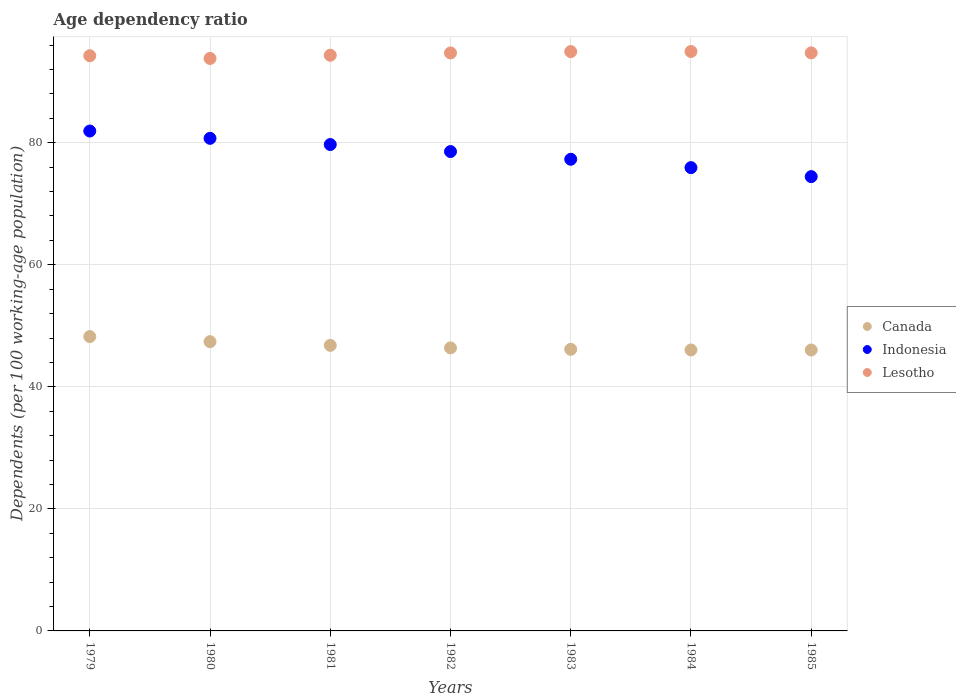What is the age dependency ratio in in Lesotho in 1982?
Provide a short and direct response. 94.71. Across all years, what is the maximum age dependency ratio in in Indonesia?
Keep it short and to the point. 81.92. Across all years, what is the minimum age dependency ratio in in Indonesia?
Make the answer very short. 74.45. In which year was the age dependency ratio in in Indonesia maximum?
Your answer should be compact. 1979. What is the total age dependency ratio in in Canada in the graph?
Your response must be concise. 327.02. What is the difference between the age dependency ratio in in Canada in 1981 and that in 1984?
Ensure brevity in your answer.  0.75. What is the difference between the age dependency ratio in in Indonesia in 1983 and the age dependency ratio in in Lesotho in 1981?
Make the answer very short. -17.04. What is the average age dependency ratio in in Canada per year?
Your answer should be compact. 46.72. In the year 1985, what is the difference between the age dependency ratio in in Lesotho and age dependency ratio in in Canada?
Provide a succinct answer. 48.69. What is the ratio of the age dependency ratio in in Canada in 1980 to that in 1981?
Provide a short and direct response. 1.01. Is the age dependency ratio in in Indonesia in 1984 less than that in 1985?
Make the answer very short. No. What is the difference between the highest and the second highest age dependency ratio in in Canada?
Your answer should be compact. 0.84. What is the difference between the highest and the lowest age dependency ratio in in Canada?
Offer a terse response. 2.2. In how many years, is the age dependency ratio in in Canada greater than the average age dependency ratio in in Canada taken over all years?
Your answer should be very brief. 3. Is the age dependency ratio in in Indonesia strictly greater than the age dependency ratio in in Lesotho over the years?
Give a very brief answer. No. How many dotlines are there?
Give a very brief answer. 3. How many years are there in the graph?
Give a very brief answer. 7. Are the values on the major ticks of Y-axis written in scientific E-notation?
Provide a succinct answer. No. Does the graph contain any zero values?
Offer a very short reply. No. How are the legend labels stacked?
Give a very brief answer. Vertical. What is the title of the graph?
Your answer should be compact. Age dependency ratio. What is the label or title of the X-axis?
Your response must be concise. Years. What is the label or title of the Y-axis?
Ensure brevity in your answer.  Dependents (per 100 working-age population). What is the Dependents (per 100 working-age population) of Canada in 1979?
Offer a very short reply. 48.24. What is the Dependents (per 100 working-age population) in Indonesia in 1979?
Your response must be concise. 81.92. What is the Dependents (per 100 working-age population) in Lesotho in 1979?
Offer a terse response. 94.26. What is the Dependents (per 100 working-age population) in Canada in 1980?
Offer a terse response. 47.4. What is the Dependents (per 100 working-age population) in Indonesia in 1980?
Make the answer very short. 80.72. What is the Dependents (per 100 working-age population) in Lesotho in 1980?
Offer a terse response. 93.81. What is the Dependents (per 100 working-age population) of Canada in 1981?
Your response must be concise. 46.79. What is the Dependents (per 100 working-age population) in Indonesia in 1981?
Provide a short and direct response. 79.7. What is the Dependents (per 100 working-age population) in Lesotho in 1981?
Provide a short and direct response. 94.34. What is the Dependents (per 100 working-age population) of Canada in 1982?
Make the answer very short. 46.38. What is the Dependents (per 100 working-age population) in Indonesia in 1982?
Offer a terse response. 78.55. What is the Dependents (per 100 working-age population) of Lesotho in 1982?
Your response must be concise. 94.71. What is the Dependents (per 100 working-age population) of Canada in 1983?
Your answer should be compact. 46.14. What is the Dependents (per 100 working-age population) of Indonesia in 1983?
Make the answer very short. 77.29. What is the Dependents (per 100 working-age population) in Lesotho in 1983?
Give a very brief answer. 94.93. What is the Dependents (per 100 working-age population) of Canada in 1984?
Your response must be concise. 46.04. What is the Dependents (per 100 working-age population) of Indonesia in 1984?
Your response must be concise. 75.92. What is the Dependents (per 100 working-age population) in Lesotho in 1984?
Offer a terse response. 94.95. What is the Dependents (per 100 working-age population) in Canada in 1985?
Your answer should be compact. 46.03. What is the Dependents (per 100 working-age population) in Indonesia in 1985?
Make the answer very short. 74.45. What is the Dependents (per 100 working-age population) of Lesotho in 1985?
Your answer should be very brief. 94.73. Across all years, what is the maximum Dependents (per 100 working-age population) of Canada?
Your answer should be compact. 48.24. Across all years, what is the maximum Dependents (per 100 working-age population) in Indonesia?
Offer a very short reply. 81.92. Across all years, what is the maximum Dependents (per 100 working-age population) of Lesotho?
Make the answer very short. 94.95. Across all years, what is the minimum Dependents (per 100 working-age population) in Canada?
Offer a terse response. 46.03. Across all years, what is the minimum Dependents (per 100 working-age population) of Indonesia?
Your answer should be very brief. 74.45. Across all years, what is the minimum Dependents (per 100 working-age population) in Lesotho?
Ensure brevity in your answer.  93.81. What is the total Dependents (per 100 working-age population) of Canada in the graph?
Ensure brevity in your answer.  327.02. What is the total Dependents (per 100 working-age population) of Indonesia in the graph?
Provide a succinct answer. 548.55. What is the total Dependents (per 100 working-age population) of Lesotho in the graph?
Keep it short and to the point. 661.73. What is the difference between the Dependents (per 100 working-age population) of Canada in 1979 and that in 1980?
Provide a short and direct response. 0.84. What is the difference between the Dependents (per 100 working-age population) in Indonesia in 1979 and that in 1980?
Make the answer very short. 1.19. What is the difference between the Dependents (per 100 working-age population) of Lesotho in 1979 and that in 1980?
Give a very brief answer. 0.45. What is the difference between the Dependents (per 100 working-age population) of Canada in 1979 and that in 1981?
Provide a succinct answer. 1.44. What is the difference between the Dependents (per 100 working-age population) in Indonesia in 1979 and that in 1981?
Provide a succinct answer. 2.21. What is the difference between the Dependents (per 100 working-age population) in Lesotho in 1979 and that in 1981?
Ensure brevity in your answer.  -0.08. What is the difference between the Dependents (per 100 working-age population) in Canada in 1979 and that in 1982?
Make the answer very short. 1.86. What is the difference between the Dependents (per 100 working-age population) in Indonesia in 1979 and that in 1982?
Your answer should be compact. 3.36. What is the difference between the Dependents (per 100 working-age population) of Lesotho in 1979 and that in 1982?
Offer a terse response. -0.46. What is the difference between the Dependents (per 100 working-age population) in Canada in 1979 and that in 1983?
Keep it short and to the point. 2.09. What is the difference between the Dependents (per 100 working-age population) in Indonesia in 1979 and that in 1983?
Keep it short and to the point. 4.63. What is the difference between the Dependents (per 100 working-age population) of Lesotho in 1979 and that in 1983?
Your response must be concise. -0.67. What is the difference between the Dependents (per 100 working-age population) in Canada in 1979 and that in 1984?
Provide a succinct answer. 2.2. What is the difference between the Dependents (per 100 working-age population) in Indonesia in 1979 and that in 1984?
Keep it short and to the point. 6. What is the difference between the Dependents (per 100 working-age population) in Lesotho in 1979 and that in 1984?
Provide a short and direct response. -0.69. What is the difference between the Dependents (per 100 working-age population) of Canada in 1979 and that in 1985?
Give a very brief answer. 2.2. What is the difference between the Dependents (per 100 working-age population) in Indonesia in 1979 and that in 1985?
Give a very brief answer. 7.47. What is the difference between the Dependents (per 100 working-age population) in Lesotho in 1979 and that in 1985?
Make the answer very short. -0.47. What is the difference between the Dependents (per 100 working-age population) in Canada in 1980 and that in 1981?
Give a very brief answer. 0.6. What is the difference between the Dependents (per 100 working-age population) in Indonesia in 1980 and that in 1981?
Keep it short and to the point. 1.02. What is the difference between the Dependents (per 100 working-age population) in Lesotho in 1980 and that in 1981?
Your answer should be compact. -0.52. What is the difference between the Dependents (per 100 working-age population) of Canada in 1980 and that in 1982?
Provide a succinct answer. 1.02. What is the difference between the Dependents (per 100 working-age population) of Indonesia in 1980 and that in 1982?
Give a very brief answer. 2.17. What is the difference between the Dependents (per 100 working-age population) of Lesotho in 1980 and that in 1982?
Make the answer very short. -0.9. What is the difference between the Dependents (per 100 working-age population) of Canada in 1980 and that in 1983?
Provide a succinct answer. 1.25. What is the difference between the Dependents (per 100 working-age population) in Indonesia in 1980 and that in 1983?
Offer a very short reply. 3.43. What is the difference between the Dependents (per 100 working-age population) in Lesotho in 1980 and that in 1983?
Offer a terse response. -1.12. What is the difference between the Dependents (per 100 working-age population) of Canada in 1980 and that in 1984?
Keep it short and to the point. 1.36. What is the difference between the Dependents (per 100 working-age population) in Indonesia in 1980 and that in 1984?
Provide a succinct answer. 4.8. What is the difference between the Dependents (per 100 working-age population) in Lesotho in 1980 and that in 1984?
Ensure brevity in your answer.  -1.14. What is the difference between the Dependents (per 100 working-age population) of Canada in 1980 and that in 1985?
Your answer should be compact. 1.36. What is the difference between the Dependents (per 100 working-age population) in Indonesia in 1980 and that in 1985?
Your response must be concise. 6.28. What is the difference between the Dependents (per 100 working-age population) of Lesotho in 1980 and that in 1985?
Give a very brief answer. -0.92. What is the difference between the Dependents (per 100 working-age population) of Canada in 1981 and that in 1982?
Give a very brief answer. 0.42. What is the difference between the Dependents (per 100 working-age population) in Indonesia in 1981 and that in 1982?
Provide a short and direct response. 1.15. What is the difference between the Dependents (per 100 working-age population) of Lesotho in 1981 and that in 1982?
Make the answer very short. -0.38. What is the difference between the Dependents (per 100 working-age population) of Canada in 1981 and that in 1983?
Provide a short and direct response. 0.65. What is the difference between the Dependents (per 100 working-age population) in Indonesia in 1981 and that in 1983?
Keep it short and to the point. 2.41. What is the difference between the Dependents (per 100 working-age population) of Lesotho in 1981 and that in 1983?
Your response must be concise. -0.6. What is the difference between the Dependents (per 100 working-age population) of Canada in 1981 and that in 1984?
Provide a short and direct response. 0.75. What is the difference between the Dependents (per 100 working-age population) of Indonesia in 1981 and that in 1984?
Offer a terse response. 3.79. What is the difference between the Dependents (per 100 working-age population) in Lesotho in 1981 and that in 1984?
Your answer should be very brief. -0.61. What is the difference between the Dependents (per 100 working-age population) in Canada in 1981 and that in 1985?
Provide a succinct answer. 0.76. What is the difference between the Dependents (per 100 working-age population) of Indonesia in 1981 and that in 1985?
Provide a succinct answer. 5.26. What is the difference between the Dependents (per 100 working-age population) of Lesotho in 1981 and that in 1985?
Offer a very short reply. -0.39. What is the difference between the Dependents (per 100 working-age population) in Canada in 1982 and that in 1983?
Your answer should be compact. 0.23. What is the difference between the Dependents (per 100 working-age population) in Indonesia in 1982 and that in 1983?
Provide a succinct answer. 1.26. What is the difference between the Dependents (per 100 working-age population) of Lesotho in 1982 and that in 1983?
Your answer should be compact. -0.22. What is the difference between the Dependents (per 100 working-age population) in Canada in 1982 and that in 1984?
Ensure brevity in your answer.  0.34. What is the difference between the Dependents (per 100 working-age population) of Indonesia in 1982 and that in 1984?
Provide a short and direct response. 2.63. What is the difference between the Dependents (per 100 working-age population) of Lesotho in 1982 and that in 1984?
Your response must be concise. -0.23. What is the difference between the Dependents (per 100 working-age population) in Canada in 1982 and that in 1985?
Your response must be concise. 0.34. What is the difference between the Dependents (per 100 working-age population) of Indonesia in 1982 and that in 1985?
Offer a very short reply. 4.11. What is the difference between the Dependents (per 100 working-age population) in Lesotho in 1982 and that in 1985?
Offer a very short reply. -0.01. What is the difference between the Dependents (per 100 working-age population) of Canada in 1983 and that in 1984?
Keep it short and to the point. 0.1. What is the difference between the Dependents (per 100 working-age population) of Indonesia in 1983 and that in 1984?
Ensure brevity in your answer.  1.37. What is the difference between the Dependents (per 100 working-age population) of Lesotho in 1983 and that in 1984?
Your answer should be very brief. -0.02. What is the difference between the Dependents (per 100 working-age population) of Canada in 1983 and that in 1985?
Ensure brevity in your answer.  0.11. What is the difference between the Dependents (per 100 working-age population) in Indonesia in 1983 and that in 1985?
Keep it short and to the point. 2.84. What is the difference between the Dependents (per 100 working-age population) in Lesotho in 1983 and that in 1985?
Offer a terse response. 0.21. What is the difference between the Dependents (per 100 working-age population) of Canada in 1984 and that in 1985?
Your answer should be compact. 0.01. What is the difference between the Dependents (per 100 working-age population) of Indonesia in 1984 and that in 1985?
Give a very brief answer. 1.47. What is the difference between the Dependents (per 100 working-age population) in Lesotho in 1984 and that in 1985?
Give a very brief answer. 0.22. What is the difference between the Dependents (per 100 working-age population) of Canada in 1979 and the Dependents (per 100 working-age population) of Indonesia in 1980?
Provide a short and direct response. -32.49. What is the difference between the Dependents (per 100 working-age population) in Canada in 1979 and the Dependents (per 100 working-age population) in Lesotho in 1980?
Your answer should be compact. -45.58. What is the difference between the Dependents (per 100 working-age population) of Indonesia in 1979 and the Dependents (per 100 working-age population) of Lesotho in 1980?
Provide a succinct answer. -11.9. What is the difference between the Dependents (per 100 working-age population) of Canada in 1979 and the Dependents (per 100 working-age population) of Indonesia in 1981?
Make the answer very short. -31.47. What is the difference between the Dependents (per 100 working-age population) in Canada in 1979 and the Dependents (per 100 working-age population) in Lesotho in 1981?
Ensure brevity in your answer.  -46.1. What is the difference between the Dependents (per 100 working-age population) in Indonesia in 1979 and the Dependents (per 100 working-age population) in Lesotho in 1981?
Provide a short and direct response. -12.42. What is the difference between the Dependents (per 100 working-age population) of Canada in 1979 and the Dependents (per 100 working-age population) of Indonesia in 1982?
Your response must be concise. -30.32. What is the difference between the Dependents (per 100 working-age population) of Canada in 1979 and the Dependents (per 100 working-age population) of Lesotho in 1982?
Give a very brief answer. -46.48. What is the difference between the Dependents (per 100 working-age population) in Indonesia in 1979 and the Dependents (per 100 working-age population) in Lesotho in 1982?
Offer a terse response. -12.8. What is the difference between the Dependents (per 100 working-age population) in Canada in 1979 and the Dependents (per 100 working-age population) in Indonesia in 1983?
Your answer should be compact. -29.05. What is the difference between the Dependents (per 100 working-age population) in Canada in 1979 and the Dependents (per 100 working-age population) in Lesotho in 1983?
Your answer should be compact. -46.7. What is the difference between the Dependents (per 100 working-age population) of Indonesia in 1979 and the Dependents (per 100 working-age population) of Lesotho in 1983?
Offer a terse response. -13.02. What is the difference between the Dependents (per 100 working-age population) in Canada in 1979 and the Dependents (per 100 working-age population) in Indonesia in 1984?
Ensure brevity in your answer.  -27.68. What is the difference between the Dependents (per 100 working-age population) in Canada in 1979 and the Dependents (per 100 working-age population) in Lesotho in 1984?
Keep it short and to the point. -46.71. What is the difference between the Dependents (per 100 working-age population) of Indonesia in 1979 and the Dependents (per 100 working-age population) of Lesotho in 1984?
Offer a terse response. -13.03. What is the difference between the Dependents (per 100 working-age population) of Canada in 1979 and the Dependents (per 100 working-age population) of Indonesia in 1985?
Your response must be concise. -26.21. What is the difference between the Dependents (per 100 working-age population) in Canada in 1979 and the Dependents (per 100 working-age population) in Lesotho in 1985?
Your response must be concise. -46.49. What is the difference between the Dependents (per 100 working-age population) of Indonesia in 1979 and the Dependents (per 100 working-age population) of Lesotho in 1985?
Give a very brief answer. -12.81. What is the difference between the Dependents (per 100 working-age population) of Canada in 1980 and the Dependents (per 100 working-age population) of Indonesia in 1981?
Ensure brevity in your answer.  -32.31. What is the difference between the Dependents (per 100 working-age population) of Canada in 1980 and the Dependents (per 100 working-age population) of Lesotho in 1981?
Offer a terse response. -46.94. What is the difference between the Dependents (per 100 working-age population) in Indonesia in 1980 and the Dependents (per 100 working-age population) in Lesotho in 1981?
Your response must be concise. -13.61. What is the difference between the Dependents (per 100 working-age population) in Canada in 1980 and the Dependents (per 100 working-age population) in Indonesia in 1982?
Keep it short and to the point. -31.16. What is the difference between the Dependents (per 100 working-age population) of Canada in 1980 and the Dependents (per 100 working-age population) of Lesotho in 1982?
Your response must be concise. -47.32. What is the difference between the Dependents (per 100 working-age population) in Indonesia in 1980 and the Dependents (per 100 working-age population) in Lesotho in 1982?
Provide a succinct answer. -13.99. What is the difference between the Dependents (per 100 working-age population) in Canada in 1980 and the Dependents (per 100 working-age population) in Indonesia in 1983?
Your answer should be compact. -29.89. What is the difference between the Dependents (per 100 working-age population) in Canada in 1980 and the Dependents (per 100 working-age population) in Lesotho in 1983?
Ensure brevity in your answer.  -47.53. What is the difference between the Dependents (per 100 working-age population) of Indonesia in 1980 and the Dependents (per 100 working-age population) of Lesotho in 1983?
Ensure brevity in your answer.  -14.21. What is the difference between the Dependents (per 100 working-age population) in Canada in 1980 and the Dependents (per 100 working-age population) in Indonesia in 1984?
Offer a very short reply. -28.52. What is the difference between the Dependents (per 100 working-age population) in Canada in 1980 and the Dependents (per 100 working-age population) in Lesotho in 1984?
Your answer should be compact. -47.55. What is the difference between the Dependents (per 100 working-age population) of Indonesia in 1980 and the Dependents (per 100 working-age population) of Lesotho in 1984?
Your response must be concise. -14.23. What is the difference between the Dependents (per 100 working-age population) in Canada in 1980 and the Dependents (per 100 working-age population) in Indonesia in 1985?
Provide a succinct answer. -27.05. What is the difference between the Dependents (per 100 working-age population) in Canada in 1980 and the Dependents (per 100 working-age population) in Lesotho in 1985?
Provide a succinct answer. -47.33. What is the difference between the Dependents (per 100 working-age population) of Indonesia in 1980 and the Dependents (per 100 working-age population) of Lesotho in 1985?
Offer a terse response. -14.01. What is the difference between the Dependents (per 100 working-age population) in Canada in 1981 and the Dependents (per 100 working-age population) in Indonesia in 1982?
Your response must be concise. -31.76. What is the difference between the Dependents (per 100 working-age population) in Canada in 1981 and the Dependents (per 100 working-age population) in Lesotho in 1982?
Ensure brevity in your answer.  -47.92. What is the difference between the Dependents (per 100 working-age population) in Indonesia in 1981 and the Dependents (per 100 working-age population) in Lesotho in 1982?
Provide a short and direct response. -15.01. What is the difference between the Dependents (per 100 working-age population) in Canada in 1981 and the Dependents (per 100 working-age population) in Indonesia in 1983?
Provide a succinct answer. -30.5. What is the difference between the Dependents (per 100 working-age population) of Canada in 1981 and the Dependents (per 100 working-age population) of Lesotho in 1983?
Provide a short and direct response. -48.14. What is the difference between the Dependents (per 100 working-age population) of Indonesia in 1981 and the Dependents (per 100 working-age population) of Lesotho in 1983?
Provide a succinct answer. -15.23. What is the difference between the Dependents (per 100 working-age population) of Canada in 1981 and the Dependents (per 100 working-age population) of Indonesia in 1984?
Provide a short and direct response. -29.13. What is the difference between the Dependents (per 100 working-age population) in Canada in 1981 and the Dependents (per 100 working-age population) in Lesotho in 1984?
Ensure brevity in your answer.  -48.16. What is the difference between the Dependents (per 100 working-age population) in Indonesia in 1981 and the Dependents (per 100 working-age population) in Lesotho in 1984?
Ensure brevity in your answer.  -15.25. What is the difference between the Dependents (per 100 working-age population) of Canada in 1981 and the Dependents (per 100 working-age population) of Indonesia in 1985?
Keep it short and to the point. -27.65. What is the difference between the Dependents (per 100 working-age population) in Canada in 1981 and the Dependents (per 100 working-age population) in Lesotho in 1985?
Make the answer very short. -47.93. What is the difference between the Dependents (per 100 working-age population) of Indonesia in 1981 and the Dependents (per 100 working-age population) of Lesotho in 1985?
Your answer should be very brief. -15.02. What is the difference between the Dependents (per 100 working-age population) of Canada in 1982 and the Dependents (per 100 working-age population) of Indonesia in 1983?
Make the answer very short. -30.91. What is the difference between the Dependents (per 100 working-age population) of Canada in 1982 and the Dependents (per 100 working-age population) of Lesotho in 1983?
Ensure brevity in your answer.  -48.55. What is the difference between the Dependents (per 100 working-age population) in Indonesia in 1982 and the Dependents (per 100 working-age population) in Lesotho in 1983?
Your answer should be very brief. -16.38. What is the difference between the Dependents (per 100 working-age population) of Canada in 1982 and the Dependents (per 100 working-age population) of Indonesia in 1984?
Keep it short and to the point. -29.54. What is the difference between the Dependents (per 100 working-age population) of Canada in 1982 and the Dependents (per 100 working-age population) of Lesotho in 1984?
Offer a very short reply. -48.57. What is the difference between the Dependents (per 100 working-age population) of Indonesia in 1982 and the Dependents (per 100 working-age population) of Lesotho in 1984?
Ensure brevity in your answer.  -16.4. What is the difference between the Dependents (per 100 working-age population) in Canada in 1982 and the Dependents (per 100 working-age population) in Indonesia in 1985?
Your response must be concise. -28.07. What is the difference between the Dependents (per 100 working-age population) of Canada in 1982 and the Dependents (per 100 working-age population) of Lesotho in 1985?
Offer a very short reply. -48.35. What is the difference between the Dependents (per 100 working-age population) in Indonesia in 1982 and the Dependents (per 100 working-age population) in Lesotho in 1985?
Provide a short and direct response. -16.17. What is the difference between the Dependents (per 100 working-age population) in Canada in 1983 and the Dependents (per 100 working-age population) in Indonesia in 1984?
Provide a succinct answer. -29.78. What is the difference between the Dependents (per 100 working-age population) of Canada in 1983 and the Dependents (per 100 working-age population) of Lesotho in 1984?
Give a very brief answer. -48.81. What is the difference between the Dependents (per 100 working-age population) of Indonesia in 1983 and the Dependents (per 100 working-age population) of Lesotho in 1984?
Offer a terse response. -17.66. What is the difference between the Dependents (per 100 working-age population) of Canada in 1983 and the Dependents (per 100 working-age population) of Indonesia in 1985?
Keep it short and to the point. -28.3. What is the difference between the Dependents (per 100 working-age population) in Canada in 1983 and the Dependents (per 100 working-age population) in Lesotho in 1985?
Offer a very short reply. -48.58. What is the difference between the Dependents (per 100 working-age population) in Indonesia in 1983 and the Dependents (per 100 working-age population) in Lesotho in 1985?
Your answer should be very brief. -17.44. What is the difference between the Dependents (per 100 working-age population) in Canada in 1984 and the Dependents (per 100 working-age population) in Indonesia in 1985?
Your answer should be compact. -28.41. What is the difference between the Dependents (per 100 working-age population) of Canada in 1984 and the Dependents (per 100 working-age population) of Lesotho in 1985?
Offer a very short reply. -48.69. What is the difference between the Dependents (per 100 working-age population) of Indonesia in 1984 and the Dependents (per 100 working-age population) of Lesotho in 1985?
Offer a terse response. -18.81. What is the average Dependents (per 100 working-age population) of Canada per year?
Make the answer very short. 46.72. What is the average Dependents (per 100 working-age population) of Indonesia per year?
Your answer should be very brief. 78.36. What is the average Dependents (per 100 working-age population) of Lesotho per year?
Give a very brief answer. 94.53. In the year 1979, what is the difference between the Dependents (per 100 working-age population) of Canada and Dependents (per 100 working-age population) of Indonesia?
Offer a very short reply. -33.68. In the year 1979, what is the difference between the Dependents (per 100 working-age population) of Canada and Dependents (per 100 working-age population) of Lesotho?
Give a very brief answer. -46.02. In the year 1979, what is the difference between the Dependents (per 100 working-age population) in Indonesia and Dependents (per 100 working-age population) in Lesotho?
Offer a very short reply. -12.34. In the year 1980, what is the difference between the Dependents (per 100 working-age population) in Canada and Dependents (per 100 working-age population) in Indonesia?
Make the answer very short. -33.32. In the year 1980, what is the difference between the Dependents (per 100 working-age population) of Canada and Dependents (per 100 working-age population) of Lesotho?
Your response must be concise. -46.41. In the year 1980, what is the difference between the Dependents (per 100 working-age population) in Indonesia and Dependents (per 100 working-age population) in Lesotho?
Keep it short and to the point. -13.09. In the year 1981, what is the difference between the Dependents (per 100 working-age population) of Canada and Dependents (per 100 working-age population) of Indonesia?
Offer a terse response. -32.91. In the year 1981, what is the difference between the Dependents (per 100 working-age population) in Canada and Dependents (per 100 working-age population) in Lesotho?
Offer a very short reply. -47.54. In the year 1981, what is the difference between the Dependents (per 100 working-age population) in Indonesia and Dependents (per 100 working-age population) in Lesotho?
Your answer should be very brief. -14.63. In the year 1982, what is the difference between the Dependents (per 100 working-age population) in Canada and Dependents (per 100 working-age population) in Indonesia?
Make the answer very short. -32.18. In the year 1982, what is the difference between the Dependents (per 100 working-age population) in Canada and Dependents (per 100 working-age population) in Lesotho?
Provide a short and direct response. -48.34. In the year 1982, what is the difference between the Dependents (per 100 working-age population) in Indonesia and Dependents (per 100 working-age population) in Lesotho?
Your response must be concise. -16.16. In the year 1983, what is the difference between the Dependents (per 100 working-age population) of Canada and Dependents (per 100 working-age population) of Indonesia?
Your answer should be compact. -31.15. In the year 1983, what is the difference between the Dependents (per 100 working-age population) in Canada and Dependents (per 100 working-age population) in Lesotho?
Give a very brief answer. -48.79. In the year 1983, what is the difference between the Dependents (per 100 working-age population) in Indonesia and Dependents (per 100 working-age population) in Lesotho?
Keep it short and to the point. -17.64. In the year 1984, what is the difference between the Dependents (per 100 working-age population) of Canada and Dependents (per 100 working-age population) of Indonesia?
Provide a succinct answer. -29.88. In the year 1984, what is the difference between the Dependents (per 100 working-age population) of Canada and Dependents (per 100 working-age population) of Lesotho?
Your answer should be very brief. -48.91. In the year 1984, what is the difference between the Dependents (per 100 working-age population) of Indonesia and Dependents (per 100 working-age population) of Lesotho?
Your answer should be very brief. -19.03. In the year 1985, what is the difference between the Dependents (per 100 working-age population) of Canada and Dependents (per 100 working-age population) of Indonesia?
Give a very brief answer. -28.41. In the year 1985, what is the difference between the Dependents (per 100 working-age population) in Canada and Dependents (per 100 working-age population) in Lesotho?
Make the answer very short. -48.69. In the year 1985, what is the difference between the Dependents (per 100 working-age population) of Indonesia and Dependents (per 100 working-age population) of Lesotho?
Provide a succinct answer. -20.28. What is the ratio of the Dependents (per 100 working-age population) in Canada in 1979 to that in 1980?
Make the answer very short. 1.02. What is the ratio of the Dependents (per 100 working-age population) in Indonesia in 1979 to that in 1980?
Your answer should be compact. 1.01. What is the ratio of the Dependents (per 100 working-age population) in Lesotho in 1979 to that in 1980?
Provide a short and direct response. 1. What is the ratio of the Dependents (per 100 working-age population) in Canada in 1979 to that in 1981?
Offer a very short reply. 1.03. What is the ratio of the Dependents (per 100 working-age population) of Indonesia in 1979 to that in 1981?
Provide a short and direct response. 1.03. What is the ratio of the Dependents (per 100 working-age population) in Lesotho in 1979 to that in 1981?
Ensure brevity in your answer.  1. What is the ratio of the Dependents (per 100 working-age population) in Canada in 1979 to that in 1982?
Provide a short and direct response. 1.04. What is the ratio of the Dependents (per 100 working-age population) in Indonesia in 1979 to that in 1982?
Give a very brief answer. 1.04. What is the ratio of the Dependents (per 100 working-age population) of Lesotho in 1979 to that in 1982?
Your response must be concise. 1. What is the ratio of the Dependents (per 100 working-age population) in Canada in 1979 to that in 1983?
Make the answer very short. 1.05. What is the ratio of the Dependents (per 100 working-age population) of Indonesia in 1979 to that in 1983?
Keep it short and to the point. 1.06. What is the ratio of the Dependents (per 100 working-age population) of Canada in 1979 to that in 1984?
Ensure brevity in your answer.  1.05. What is the ratio of the Dependents (per 100 working-age population) in Indonesia in 1979 to that in 1984?
Provide a succinct answer. 1.08. What is the ratio of the Dependents (per 100 working-age population) of Lesotho in 1979 to that in 1984?
Ensure brevity in your answer.  0.99. What is the ratio of the Dependents (per 100 working-age population) of Canada in 1979 to that in 1985?
Give a very brief answer. 1.05. What is the ratio of the Dependents (per 100 working-age population) of Indonesia in 1979 to that in 1985?
Keep it short and to the point. 1.1. What is the ratio of the Dependents (per 100 working-age population) of Canada in 1980 to that in 1981?
Ensure brevity in your answer.  1.01. What is the ratio of the Dependents (per 100 working-age population) of Indonesia in 1980 to that in 1981?
Ensure brevity in your answer.  1.01. What is the ratio of the Dependents (per 100 working-age population) of Lesotho in 1980 to that in 1981?
Offer a terse response. 0.99. What is the ratio of the Dependents (per 100 working-age population) of Indonesia in 1980 to that in 1982?
Offer a very short reply. 1.03. What is the ratio of the Dependents (per 100 working-age population) of Canada in 1980 to that in 1983?
Provide a succinct answer. 1.03. What is the ratio of the Dependents (per 100 working-age population) in Indonesia in 1980 to that in 1983?
Provide a short and direct response. 1.04. What is the ratio of the Dependents (per 100 working-age population) of Canada in 1980 to that in 1984?
Your answer should be compact. 1.03. What is the ratio of the Dependents (per 100 working-age population) in Indonesia in 1980 to that in 1984?
Offer a terse response. 1.06. What is the ratio of the Dependents (per 100 working-age population) of Lesotho in 1980 to that in 1984?
Make the answer very short. 0.99. What is the ratio of the Dependents (per 100 working-age population) in Canada in 1980 to that in 1985?
Your response must be concise. 1.03. What is the ratio of the Dependents (per 100 working-age population) of Indonesia in 1980 to that in 1985?
Offer a terse response. 1.08. What is the ratio of the Dependents (per 100 working-age population) of Lesotho in 1980 to that in 1985?
Your answer should be very brief. 0.99. What is the ratio of the Dependents (per 100 working-age population) in Canada in 1981 to that in 1982?
Keep it short and to the point. 1.01. What is the ratio of the Dependents (per 100 working-age population) of Indonesia in 1981 to that in 1982?
Make the answer very short. 1.01. What is the ratio of the Dependents (per 100 working-age population) of Lesotho in 1981 to that in 1982?
Offer a very short reply. 1. What is the ratio of the Dependents (per 100 working-age population) of Canada in 1981 to that in 1983?
Ensure brevity in your answer.  1.01. What is the ratio of the Dependents (per 100 working-age population) of Indonesia in 1981 to that in 1983?
Ensure brevity in your answer.  1.03. What is the ratio of the Dependents (per 100 working-age population) in Canada in 1981 to that in 1984?
Your answer should be very brief. 1.02. What is the ratio of the Dependents (per 100 working-age population) of Indonesia in 1981 to that in 1984?
Provide a succinct answer. 1.05. What is the ratio of the Dependents (per 100 working-age population) of Canada in 1981 to that in 1985?
Your answer should be very brief. 1.02. What is the ratio of the Dependents (per 100 working-age population) in Indonesia in 1981 to that in 1985?
Ensure brevity in your answer.  1.07. What is the ratio of the Dependents (per 100 working-age population) in Indonesia in 1982 to that in 1983?
Give a very brief answer. 1.02. What is the ratio of the Dependents (per 100 working-age population) in Lesotho in 1982 to that in 1983?
Offer a very short reply. 1. What is the ratio of the Dependents (per 100 working-age population) in Canada in 1982 to that in 1984?
Provide a short and direct response. 1.01. What is the ratio of the Dependents (per 100 working-age population) of Indonesia in 1982 to that in 1984?
Keep it short and to the point. 1.03. What is the ratio of the Dependents (per 100 working-age population) in Lesotho in 1982 to that in 1984?
Provide a short and direct response. 1. What is the ratio of the Dependents (per 100 working-age population) of Canada in 1982 to that in 1985?
Give a very brief answer. 1.01. What is the ratio of the Dependents (per 100 working-age population) in Indonesia in 1982 to that in 1985?
Ensure brevity in your answer.  1.06. What is the ratio of the Dependents (per 100 working-age population) in Lesotho in 1982 to that in 1985?
Give a very brief answer. 1. What is the ratio of the Dependents (per 100 working-age population) of Indonesia in 1983 to that in 1984?
Give a very brief answer. 1.02. What is the ratio of the Dependents (per 100 working-age population) in Lesotho in 1983 to that in 1984?
Provide a succinct answer. 1. What is the ratio of the Dependents (per 100 working-age population) in Canada in 1983 to that in 1985?
Make the answer very short. 1. What is the ratio of the Dependents (per 100 working-age population) in Indonesia in 1983 to that in 1985?
Give a very brief answer. 1.04. What is the ratio of the Dependents (per 100 working-age population) in Canada in 1984 to that in 1985?
Keep it short and to the point. 1. What is the ratio of the Dependents (per 100 working-age population) in Indonesia in 1984 to that in 1985?
Your answer should be very brief. 1.02. What is the ratio of the Dependents (per 100 working-age population) of Lesotho in 1984 to that in 1985?
Provide a short and direct response. 1. What is the difference between the highest and the second highest Dependents (per 100 working-age population) of Canada?
Keep it short and to the point. 0.84. What is the difference between the highest and the second highest Dependents (per 100 working-age population) of Indonesia?
Keep it short and to the point. 1.19. What is the difference between the highest and the second highest Dependents (per 100 working-age population) of Lesotho?
Make the answer very short. 0.02. What is the difference between the highest and the lowest Dependents (per 100 working-age population) in Canada?
Ensure brevity in your answer.  2.2. What is the difference between the highest and the lowest Dependents (per 100 working-age population) of Indonesia?
Give a very brief answer. 7.47. What is the difference between the highest and the lowest Dependents (per 100 working-age population) in Lesotho?
Provide a succinct answer. 1.14. 